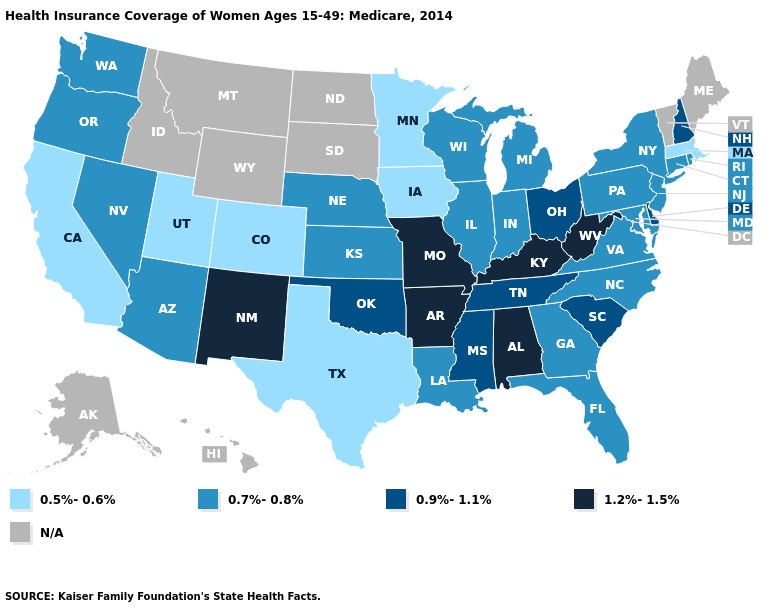What is the lowest value in the MidWest?
Quick response, please. 0.5%-0.6%. What is the value of Louisiana?
Keep it brief. 0.7%-0.8%. What is the value of Delaware?
Write a very short answer. 0.9%-1.1%. What is the lowest value in the USA?
Short answer required. 0.5%-0.6%. What is the highest value in states that border Oklahoma?
Give a very brief answer. 1.2%-1.5%. What is the lowest value in the West?
Be succinct. 0.5%-0.6%. Name the states that have a value in the range 0.5%-0.6%?
Quick response, please. California, Colorado, Iowa, Massachusetts, Minnesota, Texas, Utah. What is the value of New York?
Write a very short answer. 0.7%-0.8%. How many symbols are there in the legend?
Quick response, please. 5. Among the states that border Idaho , does Utah have the lowest value?
Short answer required. Yes. Name the states that have a value in the range 0.9%-1.1%?
Answer briefly. Delaware, Mississippi, New Hampshire, Ohio, Oklahoma, South Carolina, Tennessee. Name the states that have a value in the range N/A?
Give a very brief answer. Alaska, Hawaii, Idaho, Maine, Montana, North Dakota, South Dakota, Vermont, Wyoming. What is the lowest value in states that border Georgia?
Keep it brief. 0.7%-0.8%. What is the lowest value in the MidWest?
Give a very brief answer. 0.5%-0.6%. Which states have the lowest value in the USA?
Write a very short answer. California, Colorado, Iowa, Massachusetts, Minnesota, Texas, Utah. 